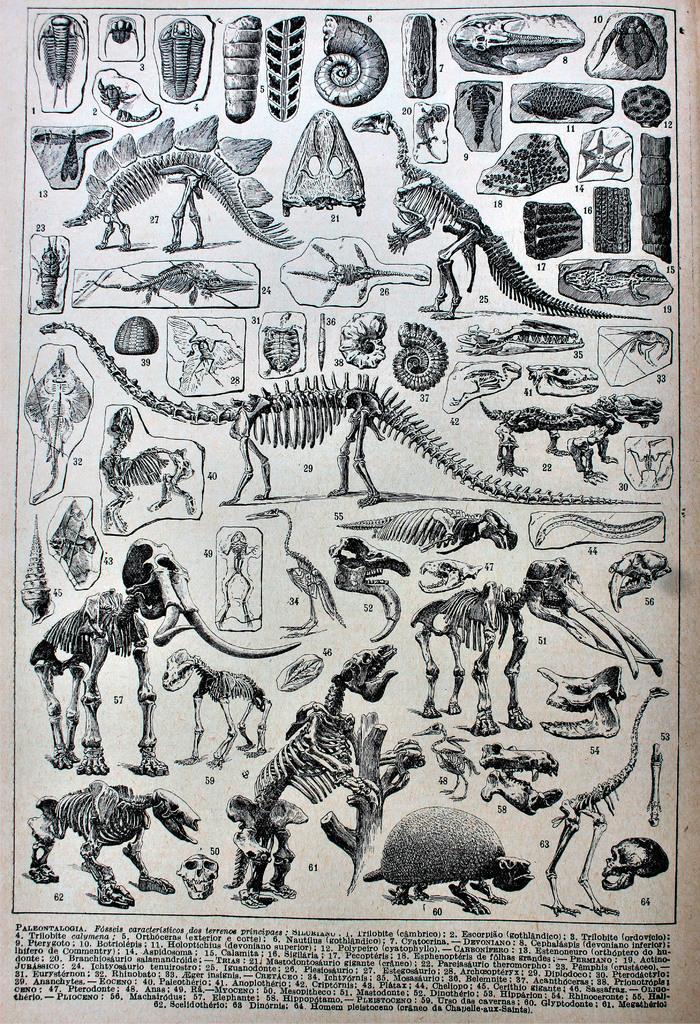In one or two sentences, can you explain what this image depicts? In this image, we can see a poster. Here we can see animals skeleton that are labeled with numbers. At the bottom of the image, we can see some text. 